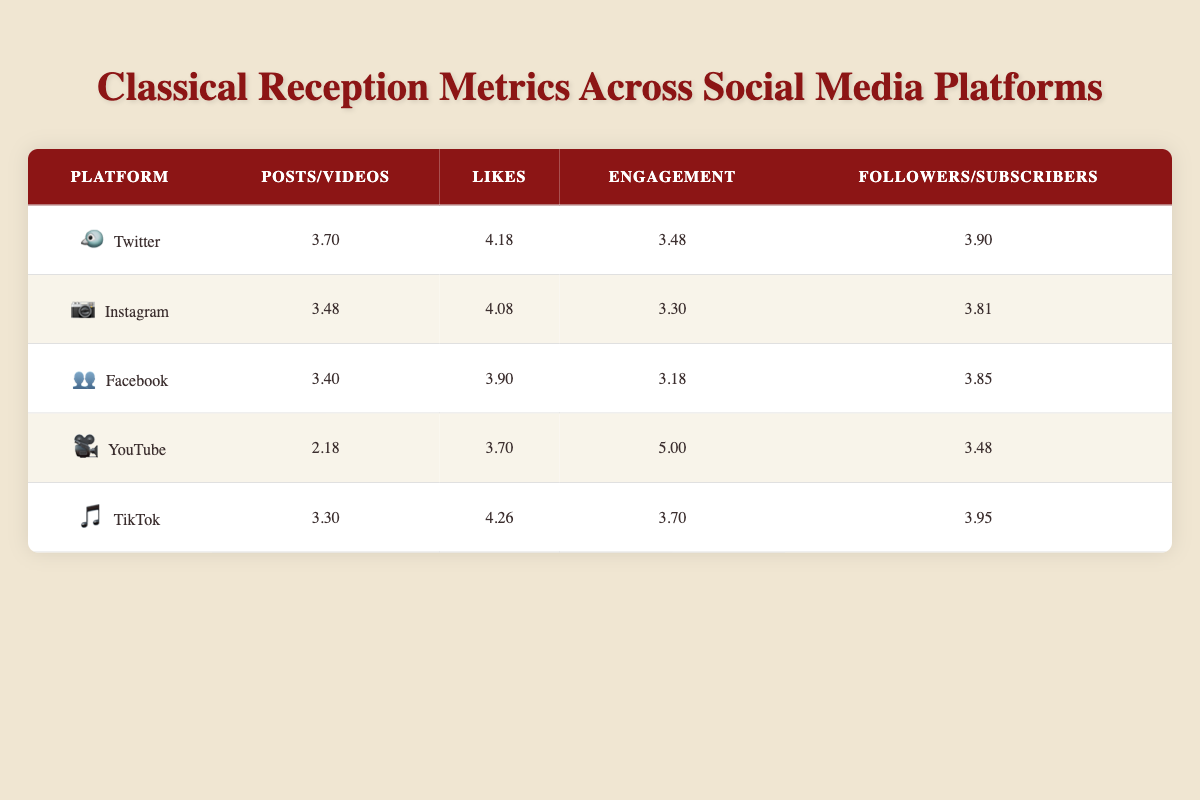What is the total number of Posts/Videos across all platforms? The total number of Posts/Videos can be calculated by summing the values from the "Posts/Videos" column: 5000 (Twitter) + 3000 (Instagram) + 2500 (Facebook) + 150 (YouTube) + 2000 (TikTok) = 12750.
Answer: 12750 Which platform has the highest number of Likes? By comparing the Likes from the table, Twitter has 15000 Likes, which is more than others: Instagram (12000), Facebook (8000), YouTube (5000), and TikTok (18000). The highest is TikTok with 18000 Likes.
Answer: TikTok Is the average number of Engagements across all platforms greater than 3.5? The Engagement values are: 3.48 (Twitter), 3.30 (Instagram), 3.18 (Facebook), 5.00 (YouTube), and 3.70 (TikTok). The total is 3.48 + 3.30 + 3.18 + 5.00 + 3.70 = 18.96, and dividing by 5 gives an average of 3.792, which is greater than 3.5.
Answer: Yes What is the difference in Followers/Subscribers between the platform with the highest and lowest values? The highest Followers/Subscribers is Twitter with 8000 and the lowest is YouTube with 3000. The difference is 8000 - 3000 = 5000.
Answer: 5000 Which platforms have an average Likes count below 4.0? The Likes counts are: Twitter (15000), Instagram (12000), Facebook (8000), YouTube (5000), TikTok (18000). The logarithmic values are: 4.18 (Twitter), 4.08 (Instagram), 3.90 (Facebook), 3.70 (YouTube), 4.26 (TikTok). The ones below 4.0 are YouTube (3.70) and Facebook (3.90).
Answer: YouTube, Facebook How many total Shares were reported across platforms that include Shares? Only Instagram, Facebook, and TikTok have Shares reported. The Shares are Instagram (0, as it's not listed directly), Facebook (1500), and TikTok (5000). The total from these platforms is 0 + 1500 + 5000 = 6500.
Answer: 6500 